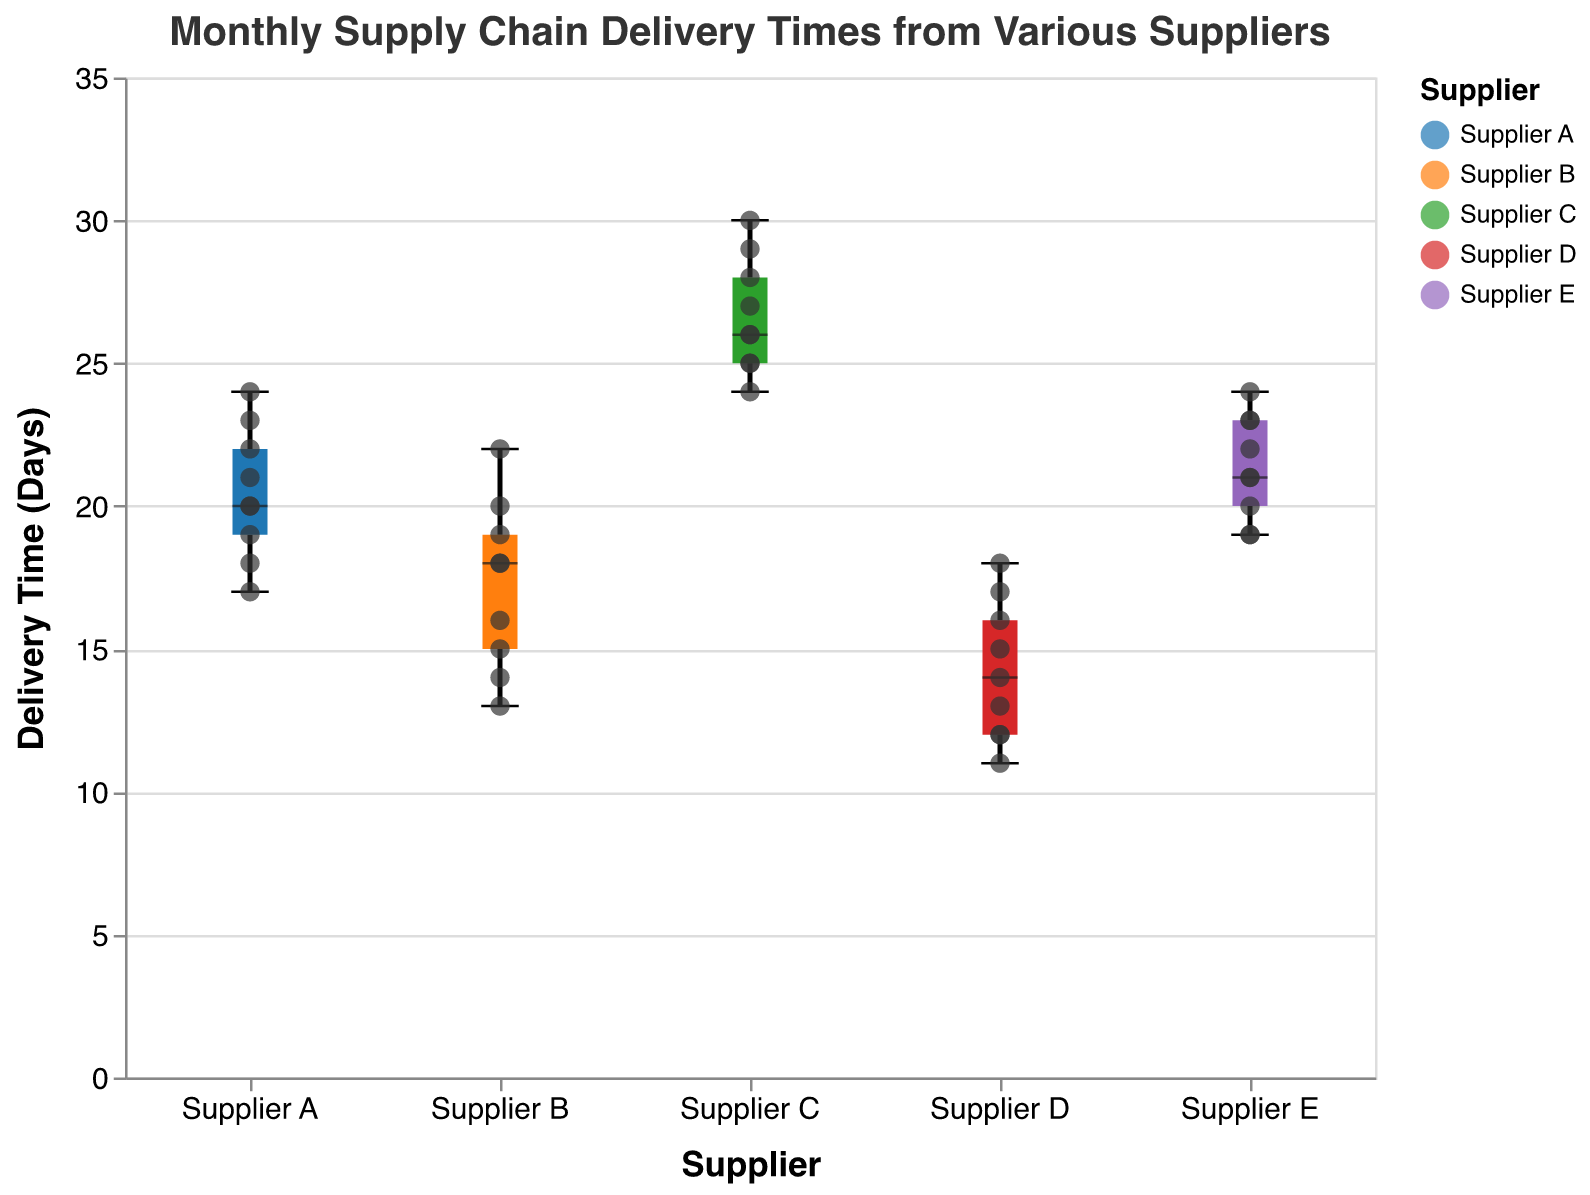What is the title of the chart? The title of the chart is typically displayed prominently at the top and provides a general overview of the content. The title here is "Monthly Supply Chain Delivery Times from Various Suppliers."
Answer: Monthly Supply Chain Delivery Times from Various Suppliers What does the y-axis represent? The y-axis is labeled to indicate what is being measured or compared across the different categories on the x-axis. In this case, it represents "Delivery Time (Days)."
Answer: Delivery Time (Days) Which supplier has the highest median delivery time? The median delivery time is typically marked by a bold line within each box in a box plot. By observing the median lines, Supplier C has the highest median delivery time.
Answer: Supplier C Which supplier shows the greatest variation in delivery times? Variation in delivery times can be assessed by the range of the box plot, from the minimum to the maximum points. Supplier C shows the greatest variation as its box plot spans the widest range on the y-axis.
Answer: Supplier C What is the median delivery time for Supplier D in January? By looking at the box plot for Supplier D in January, the median line indicates the central value of the delivery times. The median delivery time for Supplier D in January is 12.
Answer: 12 Which supplier had the lowest minimum delivery time and what was it? The minimum value for each supplier can be found at the bottom of the whisker on the box plot. The supplier with the lowest minimum delivery time is Supplier D, with a minimum delivery time of 11 days.
Answer: Supplier D, 11 days How does the median delivery time for Supplier E in March compare to Supplier A in March? To compare the medians, find the median line within the box plots for Supplier E in March and Supplier A in March. Supplier E's median delivery time in March is 21 days, while Supplier A's median is 20 days.
Answer: Supplier E's median in March is greater than Supplier A's median in March What is the interquartile range (IQR) for Supplier B in February? The IQR is the range between the first quartile (Q1) and the third quartile (Q3) in the box plot. For Supplier B in February, Q1 is 13 and Q3 is 18, so the IQR is 18 - 13 = 5 days.
Answer: 5 days Which supplier has the smallest maximum delivery time, and what is this value? The maximum value for each supplier is at the top of the whisker of the box plot. Supplier D has the smallest maximum delivery time, which is 18 days.
Answer: Supplier D, 18 days Which supplier had the most consistent delivery times across all months? Consistency can be assessed by the size of the IQR and the range of delivery times. Supplier D has relatively small IQRs and ranges in delivery times across all months, indicating the most consistent delivery times.
Answer: Supplier D 